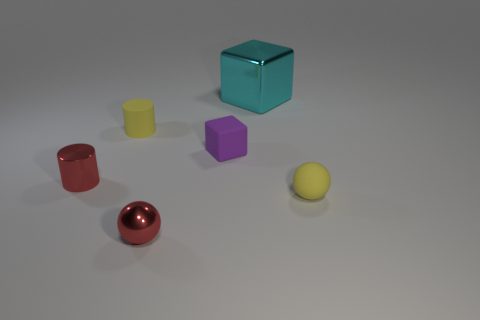How many large cubes have the same color as the metallic ball?
Your answer should be compact. 0. There is a yellow object right of the large metallic cube; is there a tiny yellow cylinder that is right of it?
Provide a succinct answer. No. What number of things are in front of the cyan block and to the right of the tiny red metal ball?
Offer a very short reply. 2. How many things are the same material as the large cyan block?
Your answer should be compact. 2. There is a yellow object that is on the right side of the metallic thing in front of the yellow ball; what is its size?
Offer a very short reply. Small. Is there another big cyan object that has the same shape as the cyan object?
Give a very brief answer. No. There is a red metal thing on the right side of the small rubber cylinder; is it the same size as the yellow thing that is right of the metal block?
Give a very brief answer. Yes. Are there fewer red metal cylinders in front of the tiny red metal sphere than purple rubber blocks in front of the small yellow sphere?
Provide a succinct answer. No. There is a cylinder that is the same color as the shiny sphere; what material is it?
Make the answer very short. Metal. What is the color of the tiny object that is behind the small purple matte object?
Provide a succinct answer. Yellow. 